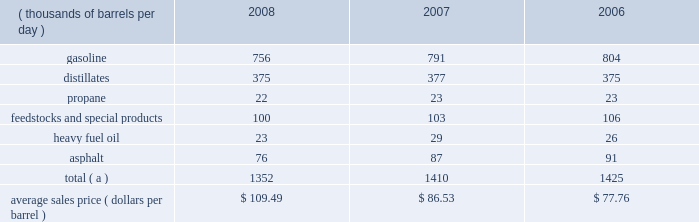The table sets forth our refined products sales by product group and our average sales price for each of the last three years .
Refined product sales ( thousands of barrels per day ) 2008 2007 2006 .
Total ( a ) 1352 1410 1425 average sales price ( dollars per barrel ) $ 109.49 $ 86.53 $ 77.76 ( a ) includes matching buy/sell volumes of 24 mbpd in 2006 .
On april 1 , 2006 , we changed our accounting for matching buy/sell arrangements as a result of a new accounting standard .
This change resulted in lower refined products sales volumes for 2008 , 2007 and the remainder of 2006 than would have been reported under our previous accounting practices .
See note 2 to the consolidated financial statements .
Gasoline and distillates 2013 we sell gasoline , gasoline blendstocks and no .
1 and no .
2 fuel oils ( including kerosene , jet fuel , diesel fuel and home heating oil ) to wholesale marketing customers in the midwest , upper great plains , gulf coast and southeastern regions of the united states .
We sold 47 percent of our gasoline volumes and 88 percent of our distillates volumes on a wholesale or spot market basis in 2008 .
The demand for gasoline is seasonal in many of our markets , with demand typically being at its highest levels during the summer months .
We have blended fuel ethanol into gasoline for over 15 years and began increasing our blending program in 2007 , in part due to federal regulations that require us to use specified volumes of renewable fuels .
We blended 57 mbpd of ethanol into gasoline in 2008 , 41 mbpd in 2007 and 35 mbpd in 2006 .
The future expansion or contraction of our ethanol blending program will be driven by the economics of the ethanol supply and by government regulations .
We sell reformulated gasoline , which is also blended with ethanol , in parts of our marketing territory , including : chicago , illinois ; louisville , kentucky ; northern kentucky ; milwaukee , wisconsin and hartford , illinois .
We also sell biodiesel-blended diesel in minnesota , illinois and kentucky .
In 2007 , we acquired a 35 percent interest in an entity which owns and operates a 110-million-gallon-per-year ethanol production facility in clymers , indiana .
We also own a 50 percent interest in an entity which owns a 110-million-gallon-per-year ethanol production facility in greenville , ohio .
The greenville plant began production in february 2008 .
Both of these facilities are managed by a co-owner .
Propane 2013 we produce propane at all seven of our refineries .
Propane is primarily used for home heating and cooking , as a feedstock within the petrochemical industry , for grain drying and as a fuel for trucks and other vehicles .
Our propane sales are typically split evenly between the home heating market and industrial consumers .
Feedstocks and special products 2013 we are a producer and marketer of petrochemicals and specialty products .
Product availability varies by refinery and includes benzene , cumene , dilute naphthalene oil , molten maleic anhydride , molten sulfur , propylene , toluene and xylene .
We market propylene , cumene and sulfur domestically to customers in the chemical industry .
We sell maleic anhydride throughout the united states and canada .
We also have the capacity to produce 1400 tons per day of anode grade coke at our robinson refinery , which is used to make carbon anodes for the aluminum smelting industry , and 2700 tons per day of fuel grade coke at the garyville refinery , which is used for power generation and in miscellaneous industrial applications .
In september 2008 , we shut down our lubes facility in catlettsburg , kentucky , and sold from inventory through december 31 , 2008 ; therefore , base oils , aromatic extracts and slack wax are no longer being produced and marketed .
In addition , we have recently discontinued production and sales of petroleum pitch and aliphatic solvents .
Heavy fuel oil 2013 we produce and market heavy oil , also known as fuel oil , residual fuel or slurry at all seven of our refineries .
Another product of crude oil , heavy oil is primarily used in the utility and ship bunkering ( fuel ) industries , though there are other more specialized uses of the product .
We also sell heavy fuel oil at our terminals in wellsville , ohio , and chattanooga , tennessee .
Asphalt 2013 we have refinery based asphalt production capacity of up to 102 mbpd .
We market asphalt through 33 owned or leased terminals throughout the midwest and southeast .
We have a broad customer base , including .
How much of refined product sales consisted of heavy fuel oil in 2008? 
Computations: (23 / 1352)
Answer: 0.01701. 